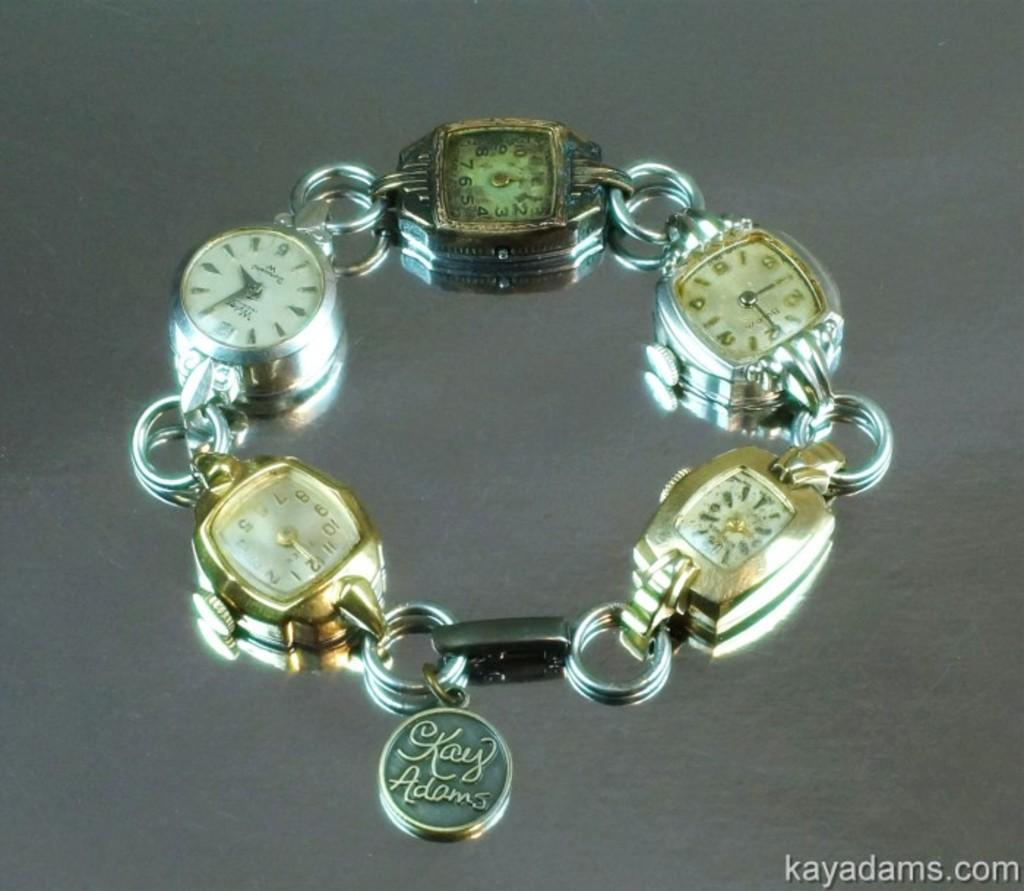<image>
Give a short and clear explanation of the subsequent image. A bracelet of watch faces has a charm saying Kay Adams dangling near the clasp. 